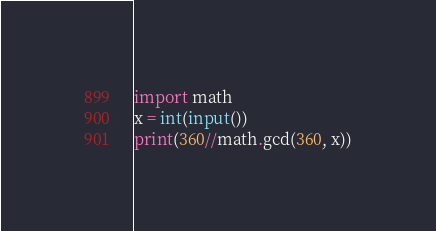Convert code to text. <code><loc_0><loc_0><loc_500><loc_500><_Cython_>import math
x = int(input())
print(360//math.gcd(360, x))</code> 